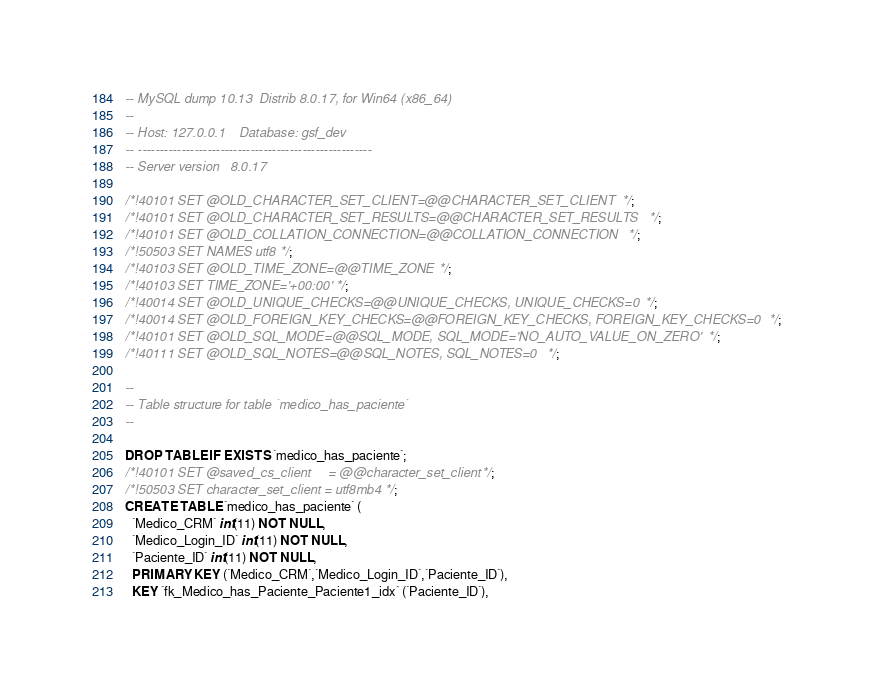Convert code to text. <code><loc_0><loc_0><loc_500><loc_500><_SQL_>-- MySQL dump 10.13  Distrib 8.0.17, for Win64 (x86_64)
--
-- Host: 127.0.0.1    Database: gsf_dev
-- ------------------------------------------------------
-- Server version	8.0.17

/*!40101 SET @OLD_CHARACTER_SET_CLIENT=@@CHARACTER_SET_CLIENT */;
/*!40101 SET @OLD_CHARACTER_SET_RESULTS=@@CHARACTER_SET_RESULTS */;
/*!40101 SET @OLD_COLLATION_CONNECTION=@@COLLATION_CONNECTION */;
/*!50503 SET NAMES utf8 */;
/*!40103 SET @OLD_TIME_ZONE=@@TIME_ZONE */;
/*!40103 SET TIME_ZONE='+00:00' */;
/*!40014 SET @OLD_UNIQUE_CHECKS=@@UNIQUE_CHECKS, UNIQUE_CHECKS=0 */;
/*!40014 SET @OLD_FOREIGN_KEY_CHECKS=@@FOREIGN_KEY_CHECKS, FOREIGN_KEY_CHECKS=0 */;
/*!40101 SET @OLD_SQL_MODE=@@SQL_MODE, SQL_MODE='NO_AUTO_VALUE_ON_ZERO' */;
/*!40111 SET @OLD_SQL_NOTES=@@SQL_NOTES, SQL_NOTES=0 */;

--
-- Table structure for table `medico_has_paciente`
--

DROP TABLE IF EXISTS `medico_has_paciente`;
/*!40101 SET @saved_cs_client     = @@character_set_client */;
/*!50503 SET character_set_client = utf8mb4 */;
CREATE TABLE `medico_has_paciente` (
  `Medico_CRM` int(11) NOT NULL,
  `Medico_Login_ID` int(11) NOT NULL,
  `Paciente_ID` int(11) NOT NULL,
  PRIMARY KEY (`Medico_CRM`,`Medico_Login_ID`,`Paciente_ID`),
  KEY `fk_Medico_has_Paciente_Paciente1_idx` (`Paciente_ID`),</code> 